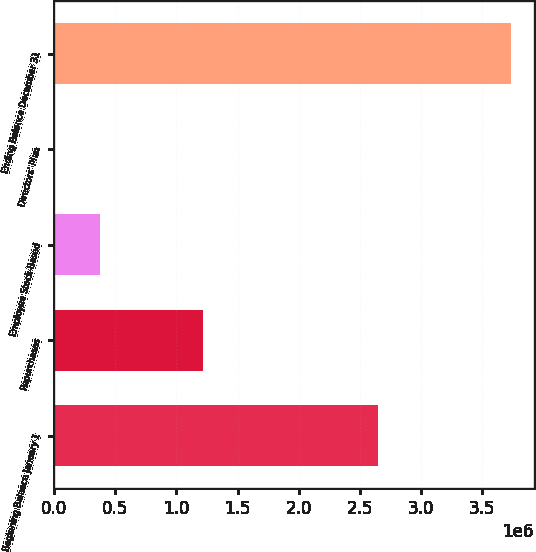Convert chart. <chart><loc_0><loc_0><loc_500><loc_500><bar_chart><fcel>Beginning Balance January 1<fcel>Repurchases<fcel>Employee Stock-Based<fcel>Directors' Plan<fcel>Ending Balance December 31<nl><fcel>2.64439e+06<fcel>1.21558e+06<fcel>373758<fcel>302<fcel>3.73486e+06<nl></chart> 